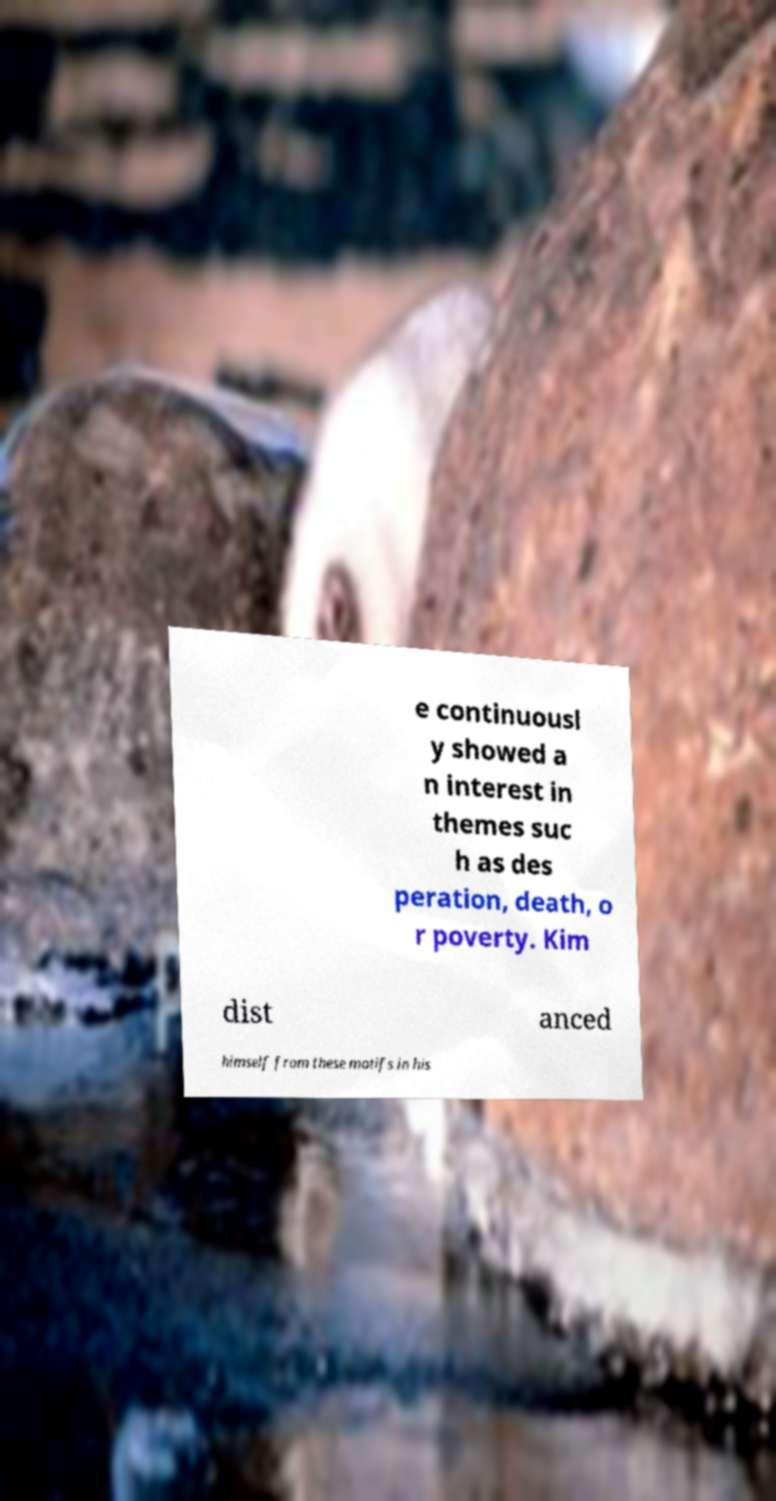Please read and relay the text visible in this image. What does it say? e continuousl y showed a n interest in themes suc h as des peration, death, o r poverty. Kim dist anced himself from these motifs in his 